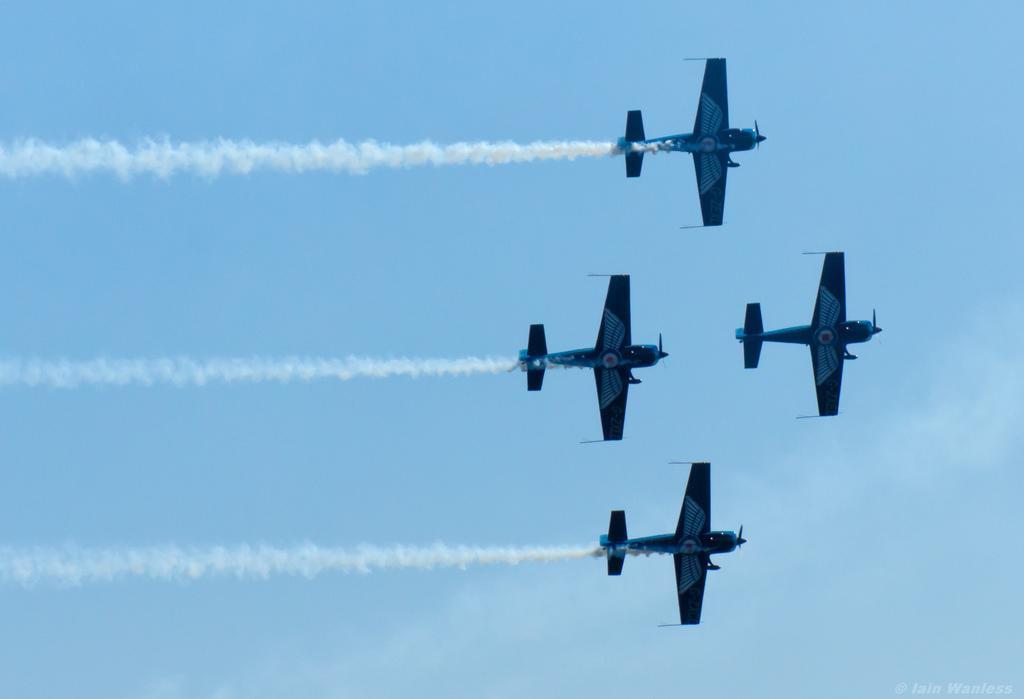How would you summarize this image in a sentence or two? In this image we can see a few airplanes are flying and in the background we can see the sky. 